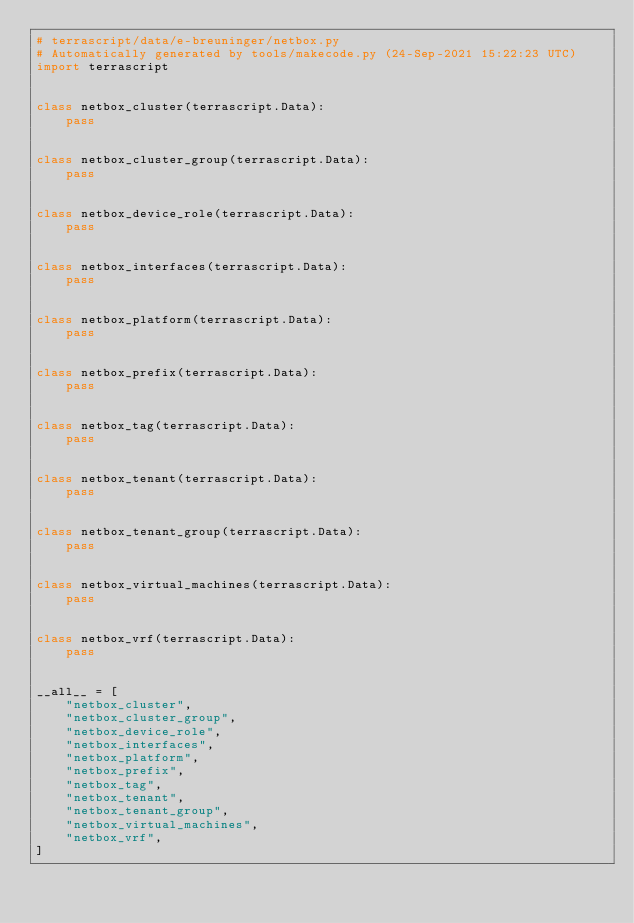Convert code to text. <code><loc_0><loc_0><loc_500><loc_500><_Python_># terrascript/data/e-breuninger/netbox.py
# Automatically generated by tools/makecode.py (24-Sep-2021 15:22:23 UTC)
import terrascript


class netbox_cluster(terrascript.Data):
    pass


class netbox_cluster_group(terrascript.Data):
    pass


class netbox_device_role(terrascript.Data):
    pass


class netbox_interfaces(terrascript.Data):
    pass


class netbox_platform(terrascript.Data):
    pass


class netbox_prefix(terrascript.Data):
    pass


class netbox_tag(terrascript.Data):
    pass


class netbox_tenant(terrascript.Data):
    pass


class netbox_tenant_group(terrascript.Data):
    pass


class netbox_virtual_machines(terrascript.Data):
    pass


class netbox_vrf(terrascript.Data):
    pass


__all__ = [
    "netbox_cluster",
    "netbox_cluster_group",
    "netbox_device_role",
    "netbox_interfaces",
    "netbox_platform",
    "netbox_prefix",
    "netbox_tag",
    "netbox_tenant",
    "netbox_tenant_group",
    "netbox_virtual_machines",
    "netbox_vrf",
]
</code> 